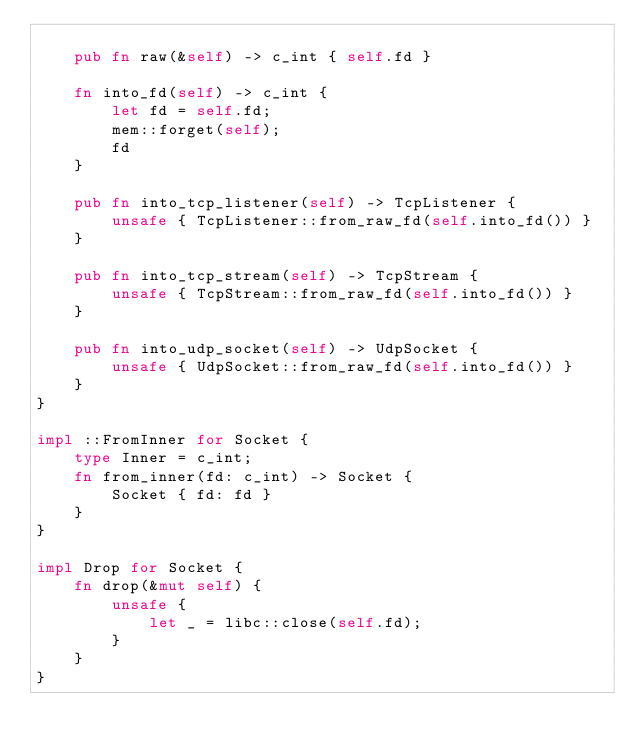<code> <loc_0><loc_0><loc_500><loc_500><_Rust_>
    pub fn raw(&self) -> c_int { self.fd }

    fn into_fd(self) -> c_int {
        let fd = self.fd;
        mem::forget(self);
        fd
    }

    pub fn into_tcp_listener(self) -> TcpListener {
        unsafe { TcpListener::from_raw_fd(self.into_fd()) }
    }

    pub fn into_tcp_stream(self) -> TcpStream {
        unsafe { TcpStream::from_raw_fd(self.into_fd()) }
    }

    pub fn into_udp_socket(self) -> UdpSocket {
        unsafe { UdpSocket::from_raw_fd(self.into_fd()) }
    }
}

impl ::FromInner for Socket {
    type Inner = c_int;
    fn from_inner(fd: c_int) -> Socket {
        Socket { fd: fd }
    }
}

impl Drop for Socket {
    fn drop(&mut self) {
        unsafe {
            let _ = libc::close(self.fd);
        }
    }
}
</code> 